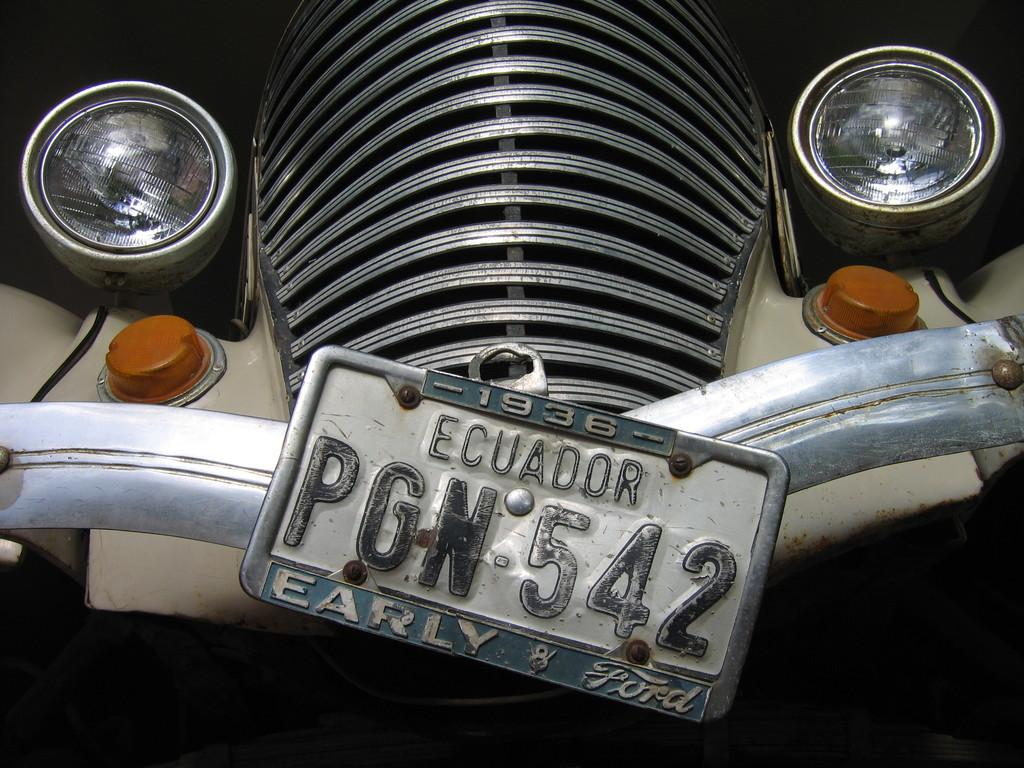What is the main subject of the image? The main subject of the image is a cover of an engine. What other parts of a vehicle can be seen in the image? There are head lamps, indicator lights, and a metal rod visible in the image. Is there any identification for the vehicle in the image? Yes, there is a number plate of a vehicle in the image. Can you see a boy rolling in the mist in the image? No, there is no boy or mist present in the image; it features parts of a vehicle. 